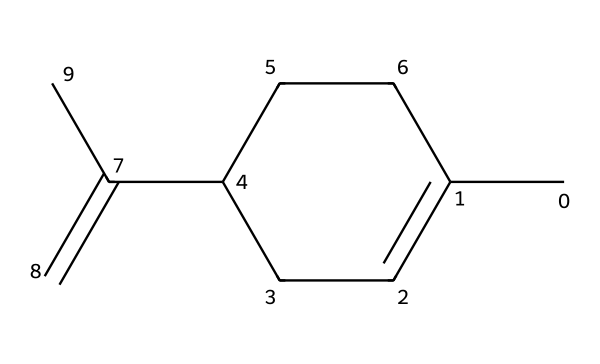What is the chemical name of this compound? The chemical structure corresponds to a compound known as limonene, which is identified based on its unique arrangement of carbon and hydrogen atoms as indicated by its SMILES representation.
Answer: limonene How many carbon atoms are in limonene? By analyzing the SMILES representation, there are 10 carbon atoms represented in the structure. Each 'C' in the SMILES denotes a carbon, totaling 10 when counted.
Answer: 10 What type of hydrocarbon is limonene? Limonene is classified as a monoterpene, which is characterized by its structure consisting of two isoprene units (10 carbon atoms in total). This classification is based on the arrangement and connectivity of carbon atoms in the structure.
Answer: monoterpene How many double bonds are present in limonene? Upon examining the chemical structure, it can be observed that limonene contains two double bonds. This is determined by locating the double bond (indicated by '=' signs) in the chemical structure.
Answer: 2 What does the presence of double bonds indicate about limonene's reactivity? The presence of double bonds in limonene suggests that it is more reactive than saturated hydrocarbons. Double bonds can participate in addition reactions, leading to greater chemical reactivity.
Answer: greater reactivity What is the primary functional group of limonene? Limonene contains a cycloalkene functional group due to the ring structure and the presence of double bonds, defining its chemical properties as a cyclic compound with unsaturation.
Answer: cycloalkene Is limonene naturally occurring? Limonene is indeed a naturally occurring compound primarily found in the peels of citrus fruits, indicating its source and the sustainable aspects related to its use in cleaning products.
Answer: yes 